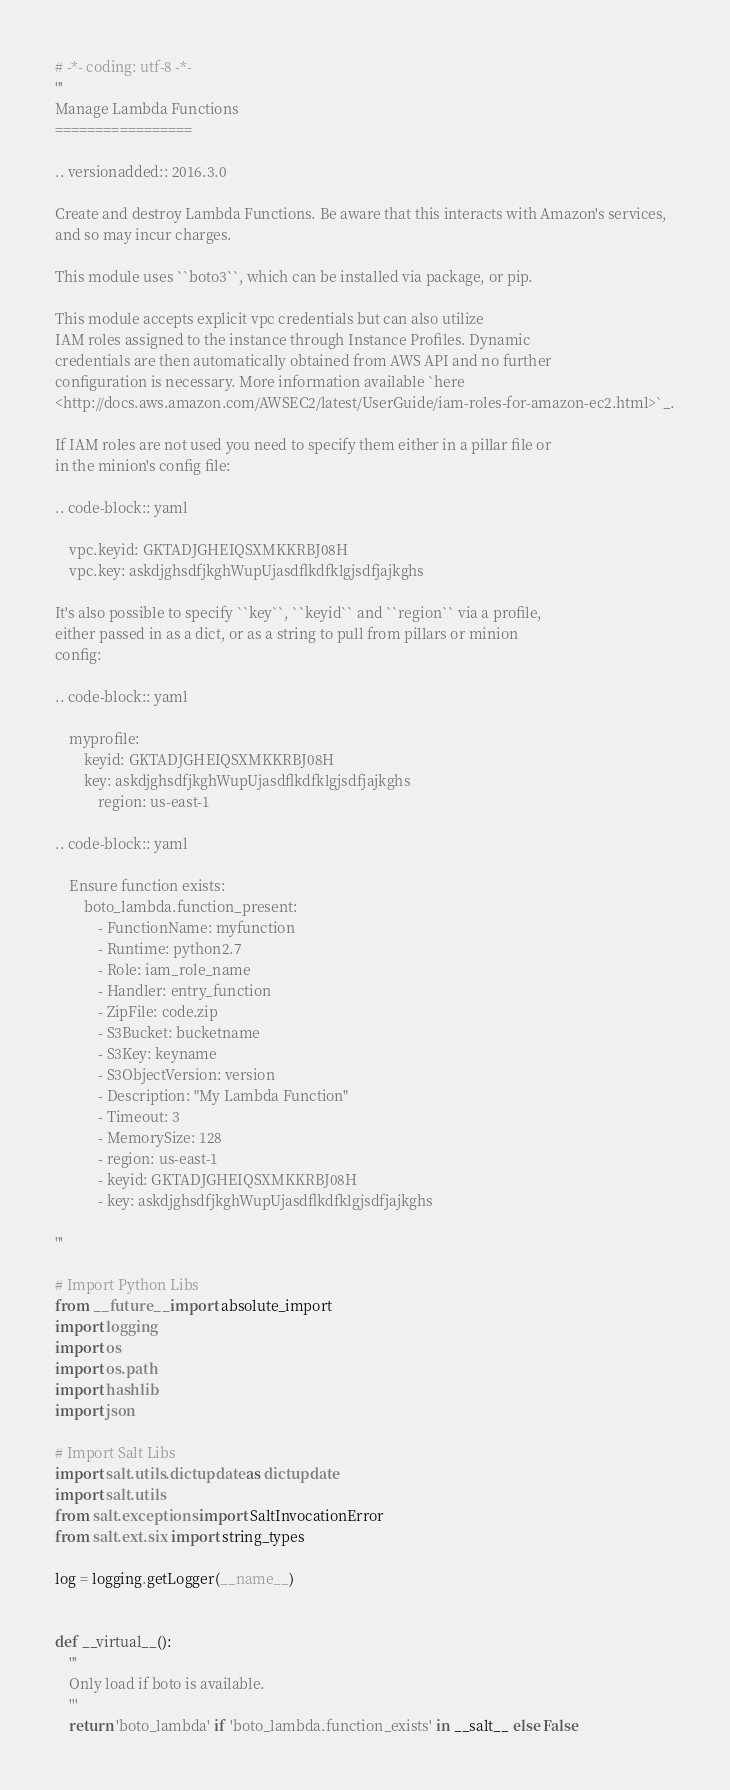Convert code to text. <code><loc_0><loc_0><loc_500><loc_500><_Python_># -*- coding: utf-8 -*-
'''
Manage Lambda Functions
=================

.. versionadded:: 2016.3.0

Create and destroy Lambda Functions. Be aware that this interacts with Amazon's services,
and so may incur charges.

This module uses ``boto3``, which can be installed via package, or pip.

This module accepts explicit vpc credentials but can also utilize
IAM roles assigned to the instance through Instance Profiles. Dynamic
credentials are then automatically obtained from AWS API and no further
configuration is necessary. More information available `here
<http://docs.aws.amazon.com/AWSEC2/latest/UserGuide/iam-roles-for-amazon-ec2.html>`_.

If IAM roles are not used you need to specify them either in a pillar file or
in the minion's config file:

.. code-block:: yaml

    vpc.keyid: GKTADJGHEIQSXMKKRBJ08H
    vpc.key: askdjghsdfjkghWupUjasdflkdfklgjsdfjajkghs

It's also possible to specify ``key``, ``keyid`` and ``region`` via a profile,
either passed in as a dict, or as a string to pull from pillars or minion
config:

.. code-block:: yaml

    myprofile:
        keyid: GKTADJGHEIQSXMKKRBJ08H
        key: askdjghsdfjkghWupUjasdflkdfklgjsdfjajkghs
            region: us-east-1

.. code-block:: yaml

    Ensure function exists:
        boto_lambda.function_present:
            - FunctionName: myfunction
            - Runtime: python2.7
            - Role: iam_role_name
            - Handler: entry_function
            - ZipFile: code.zip
            - S3Bucket: bucketname
            - S3Key: keyname
            - S3ObjectVersion: version
            - Description: "My Lambda Function"
            - Timeout: 3
            - MemorySize: 128
            - region: us-east-1
            - keyid: GKTADJGHEIQSXMKKRBJ08H
            - key: askdjghsdfjkghWupUjasdflkdfklgjsdfjajkghs

'''

# Import Python Libs
from __future__ import absolute_import
import logging
import os
import os.path
import hashlib
import json

# Import Salt Libs
import salt.utils.dictupdate as dictupdate
import salt.utils
from salt.exceptions import SaltInvocationError
from salt.ext.six import string_types

log = logging.getLogger(__name__)


def __virtual__():
    '''
    Only load if boto is available.
    '''
    return 'boto_lambda' if 'boto_lambda.function_exists' in __salt__ else False

</code> 